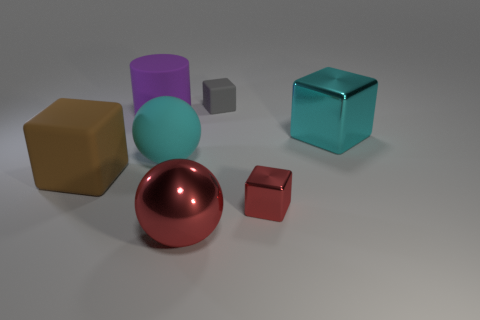Add 2 big metal blocks. How many objects exist? 9 Subtract all cylinders. How many objects are left? 6 Subtract 0 yellow spheres. How many objects are left? 7 Subtract all purple matte objects. Subtract all red metal cubes. How many objects are left? 5 Add 5 small cubes. How many small cubes are left? 7 Add 2 rubber objects. How many rubber objects exist? 6 